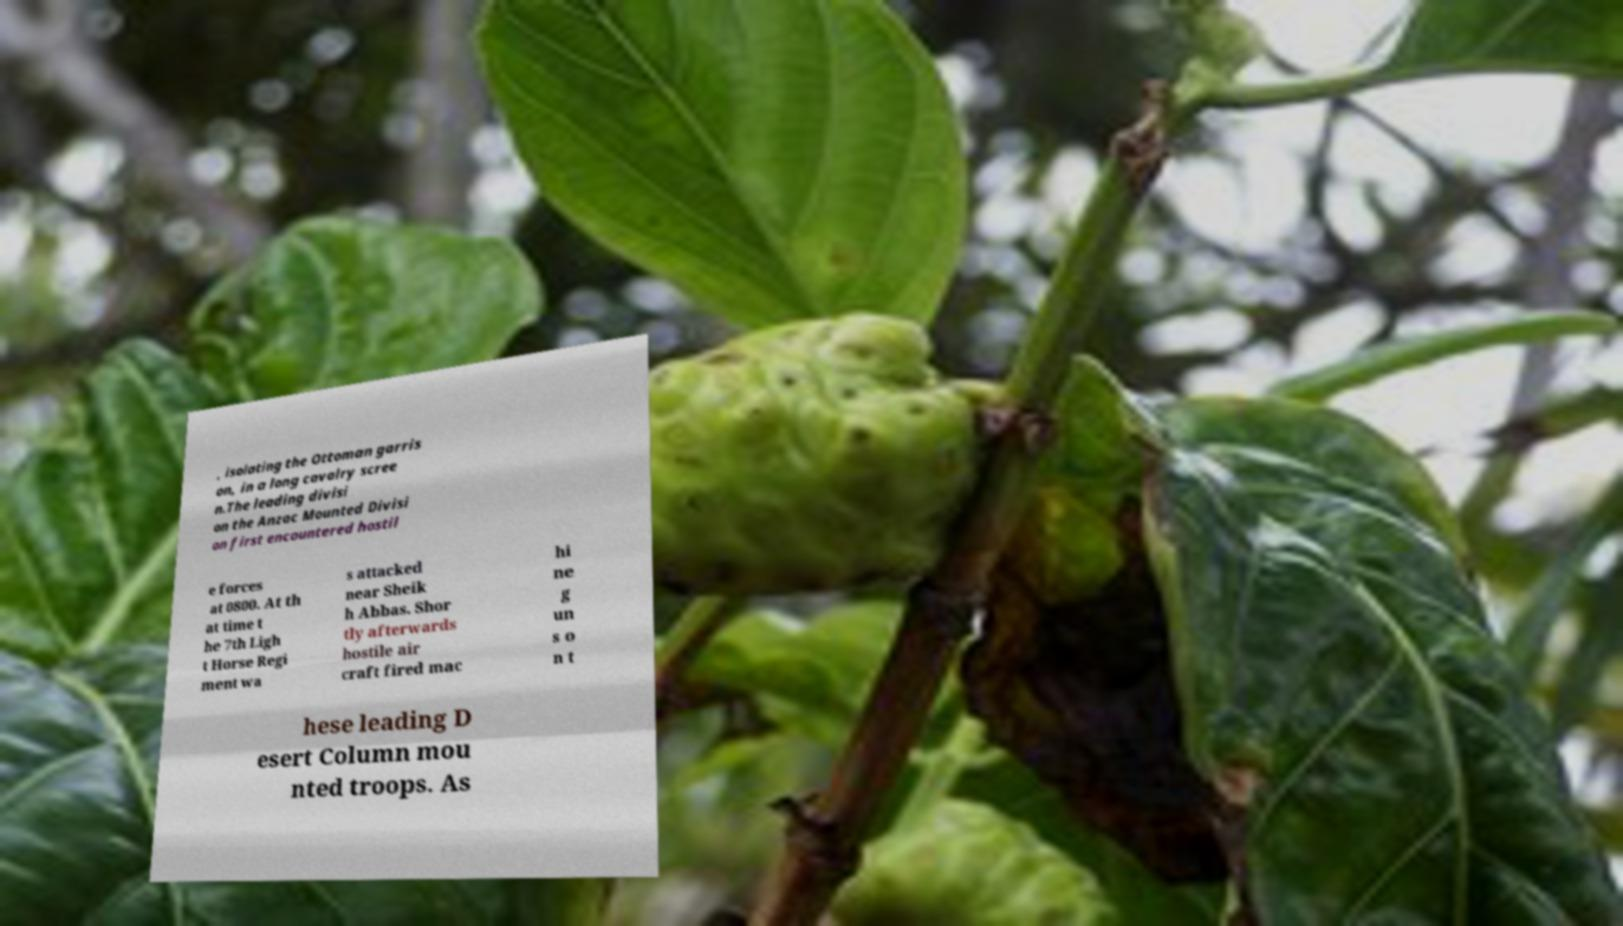Can you accurately transcribe the text from the provided image for me? , isolating the Ottoman garris on, in a long cavalry scree n.The leading divisi on the Anzac Mounted Divisi on first encountered hostil e forces at 0800. At th at time t he 7th Ligh t Horse Regi ment wa s attacked near Sheik h Abbas. Shor tly afterwards hostile air craft fired mac hi ne g un s o n t hese leading D esert Column mou nted troops. As 